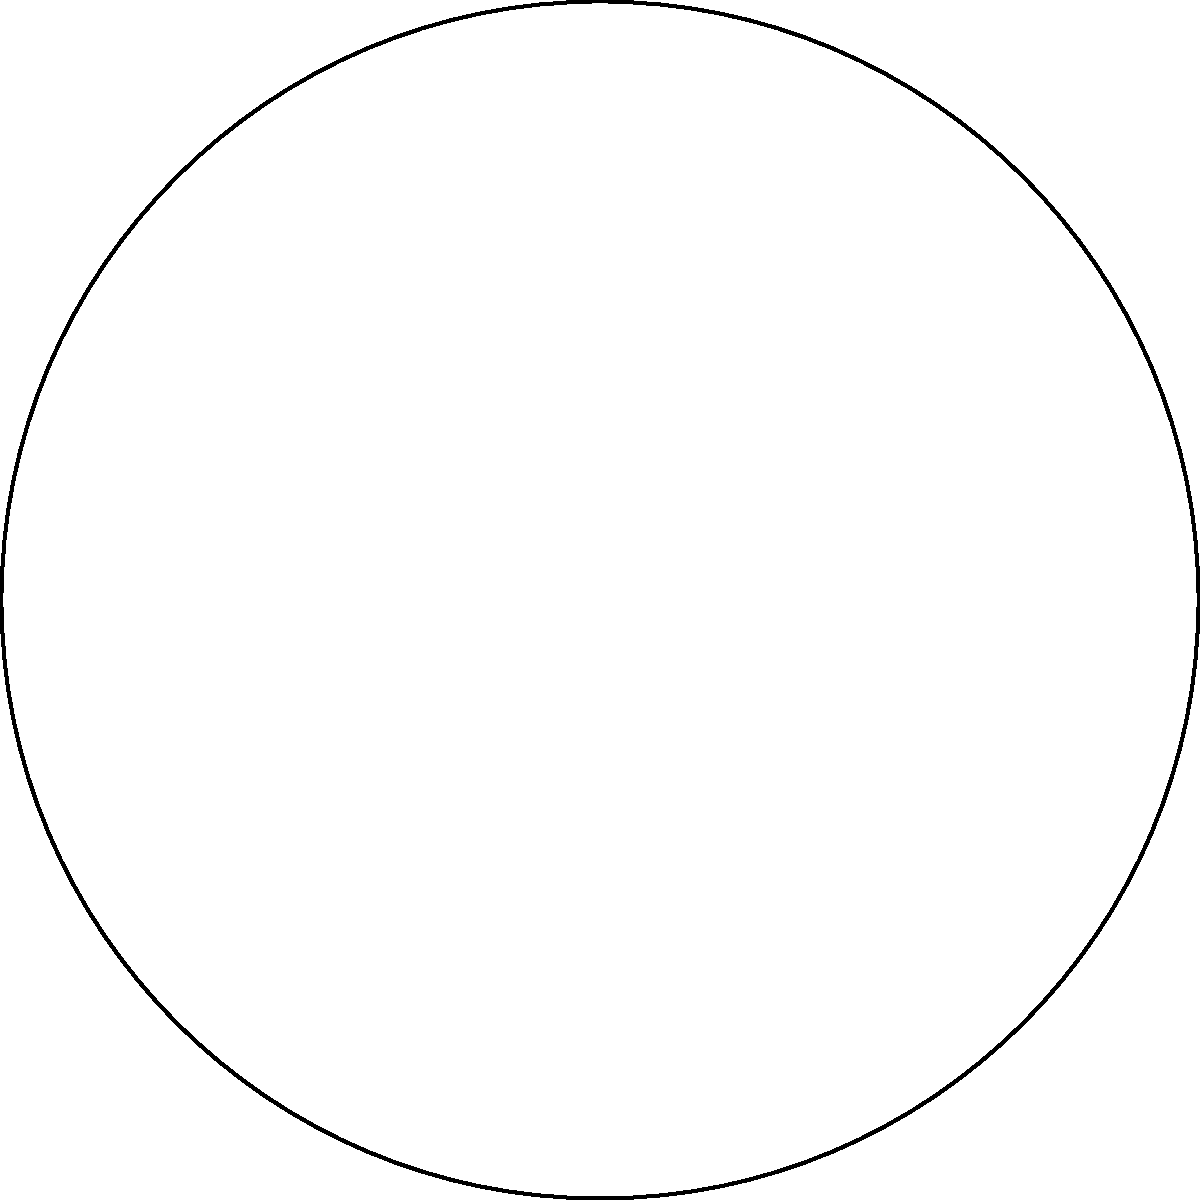At the Waukesha County Senior Fitness Center, a new circular exercise area has been designed. The total area is divided into different workout zones. One zone is a sector with a central angle of 120° and a radius of 5 meters. What is the area of this sector to the nearest square meter? To find the area of a sector, we can use the formula:

$$A = \frac{\theta}{360°} \pi r^2$$

Where:
$A$ = Area of the sector
$\theta$ = Central angle in degrees
$r$ = Radius of the circle

Given:
$\theta = 120°$
$r = 5$ meters

Let's substitute these values into the formula:

$$A = \frac{120°}{360°} \pi (5\text{ m})^2$$

Simplifying:
$$A = \frac{1}{3} \pi (25\text{ m}^2)$$

$$A = \frac{25\pi}{3} \text{ m}^2$$

Using $\pi \approx 3.14159$:

$$A \approx \frac{25 \times 3.14159}{3} \text{ m}^2$$

$$A \approx 26.18 \text{ m}^2$$

Rounding to the nearest square meter:

$$A \approx 26 \text{ m}^2$$
Answer: 26 m² 